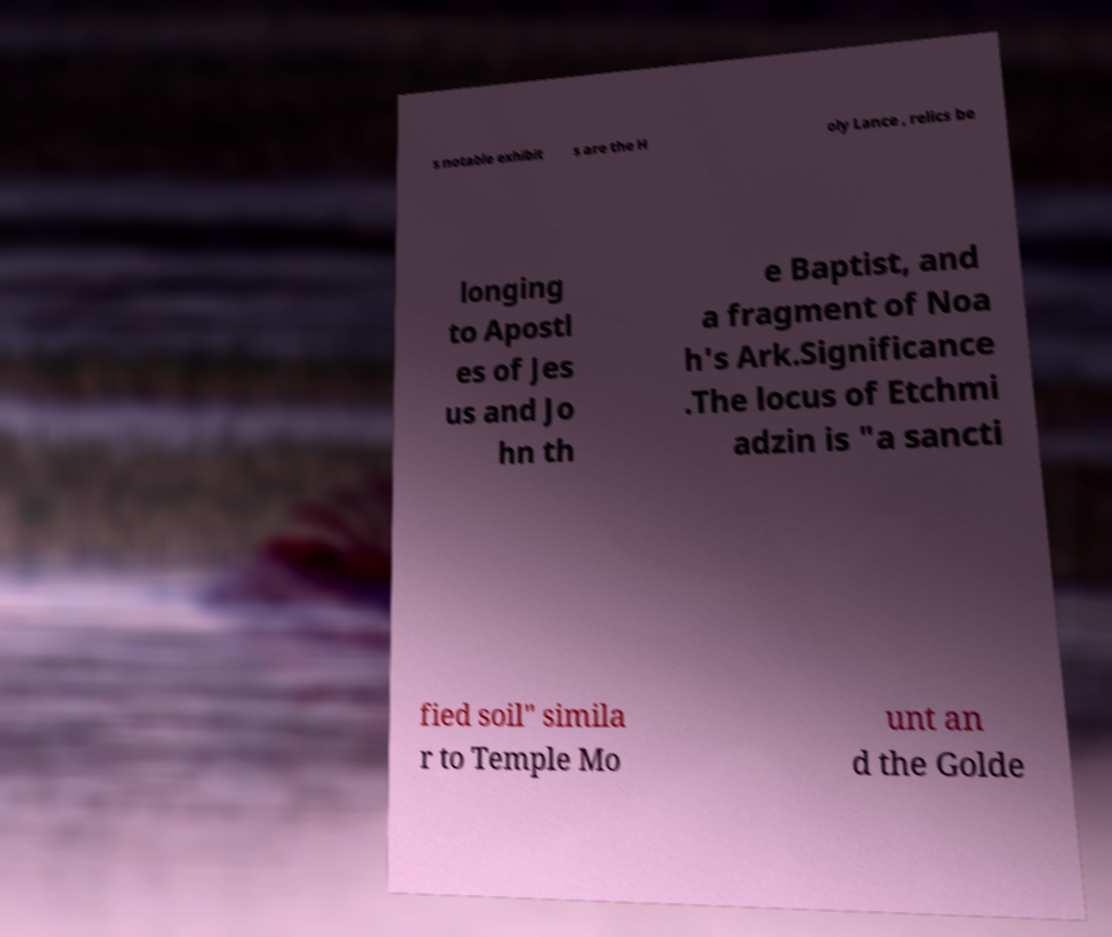I need the written content from this picture converted into text. Can you do that? s notable exhibit s are the H oly Lance , relics be longing to Apostl es of Jes us and Jo hn th e Baptist, and a fragment of Noa h's Ark.Significance .The locus of Etchmi adzin is "a sancti fied soil" simila r to Temple Mo unt an d the Golde 